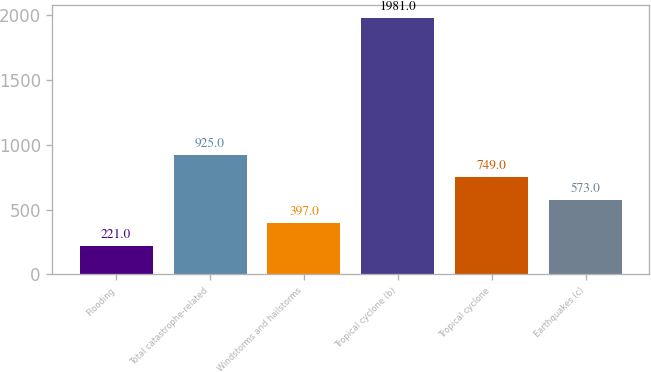Convert chart. <chart><loc_0><loc_0><loc_500><loc_500><bar_chart><fcel>Flooding<fcel>Total catastrophe-related<fcel>Windstorms and hailstorms<fcel>Tropical cyclone (b)<fcel>Tropical cyclone<fcel>Earthquakes (c)<nl><fcel>221<fcel>925<fcel>397<fcel>1981<fcel>749<fcel>573<nl></chart> 